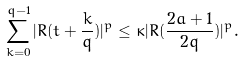Convert formula to latex. <formula><loc_0><loc_0><loc_500><loc_500>\sum _ { k = 0 } ^ { q - 1 } | R ( t + \frac { k } { q } ) | ^ { p } \leq \kappa | R ( \frac { 2 a + 1 } { 2 q } ) | ^ { p } .</formula> 